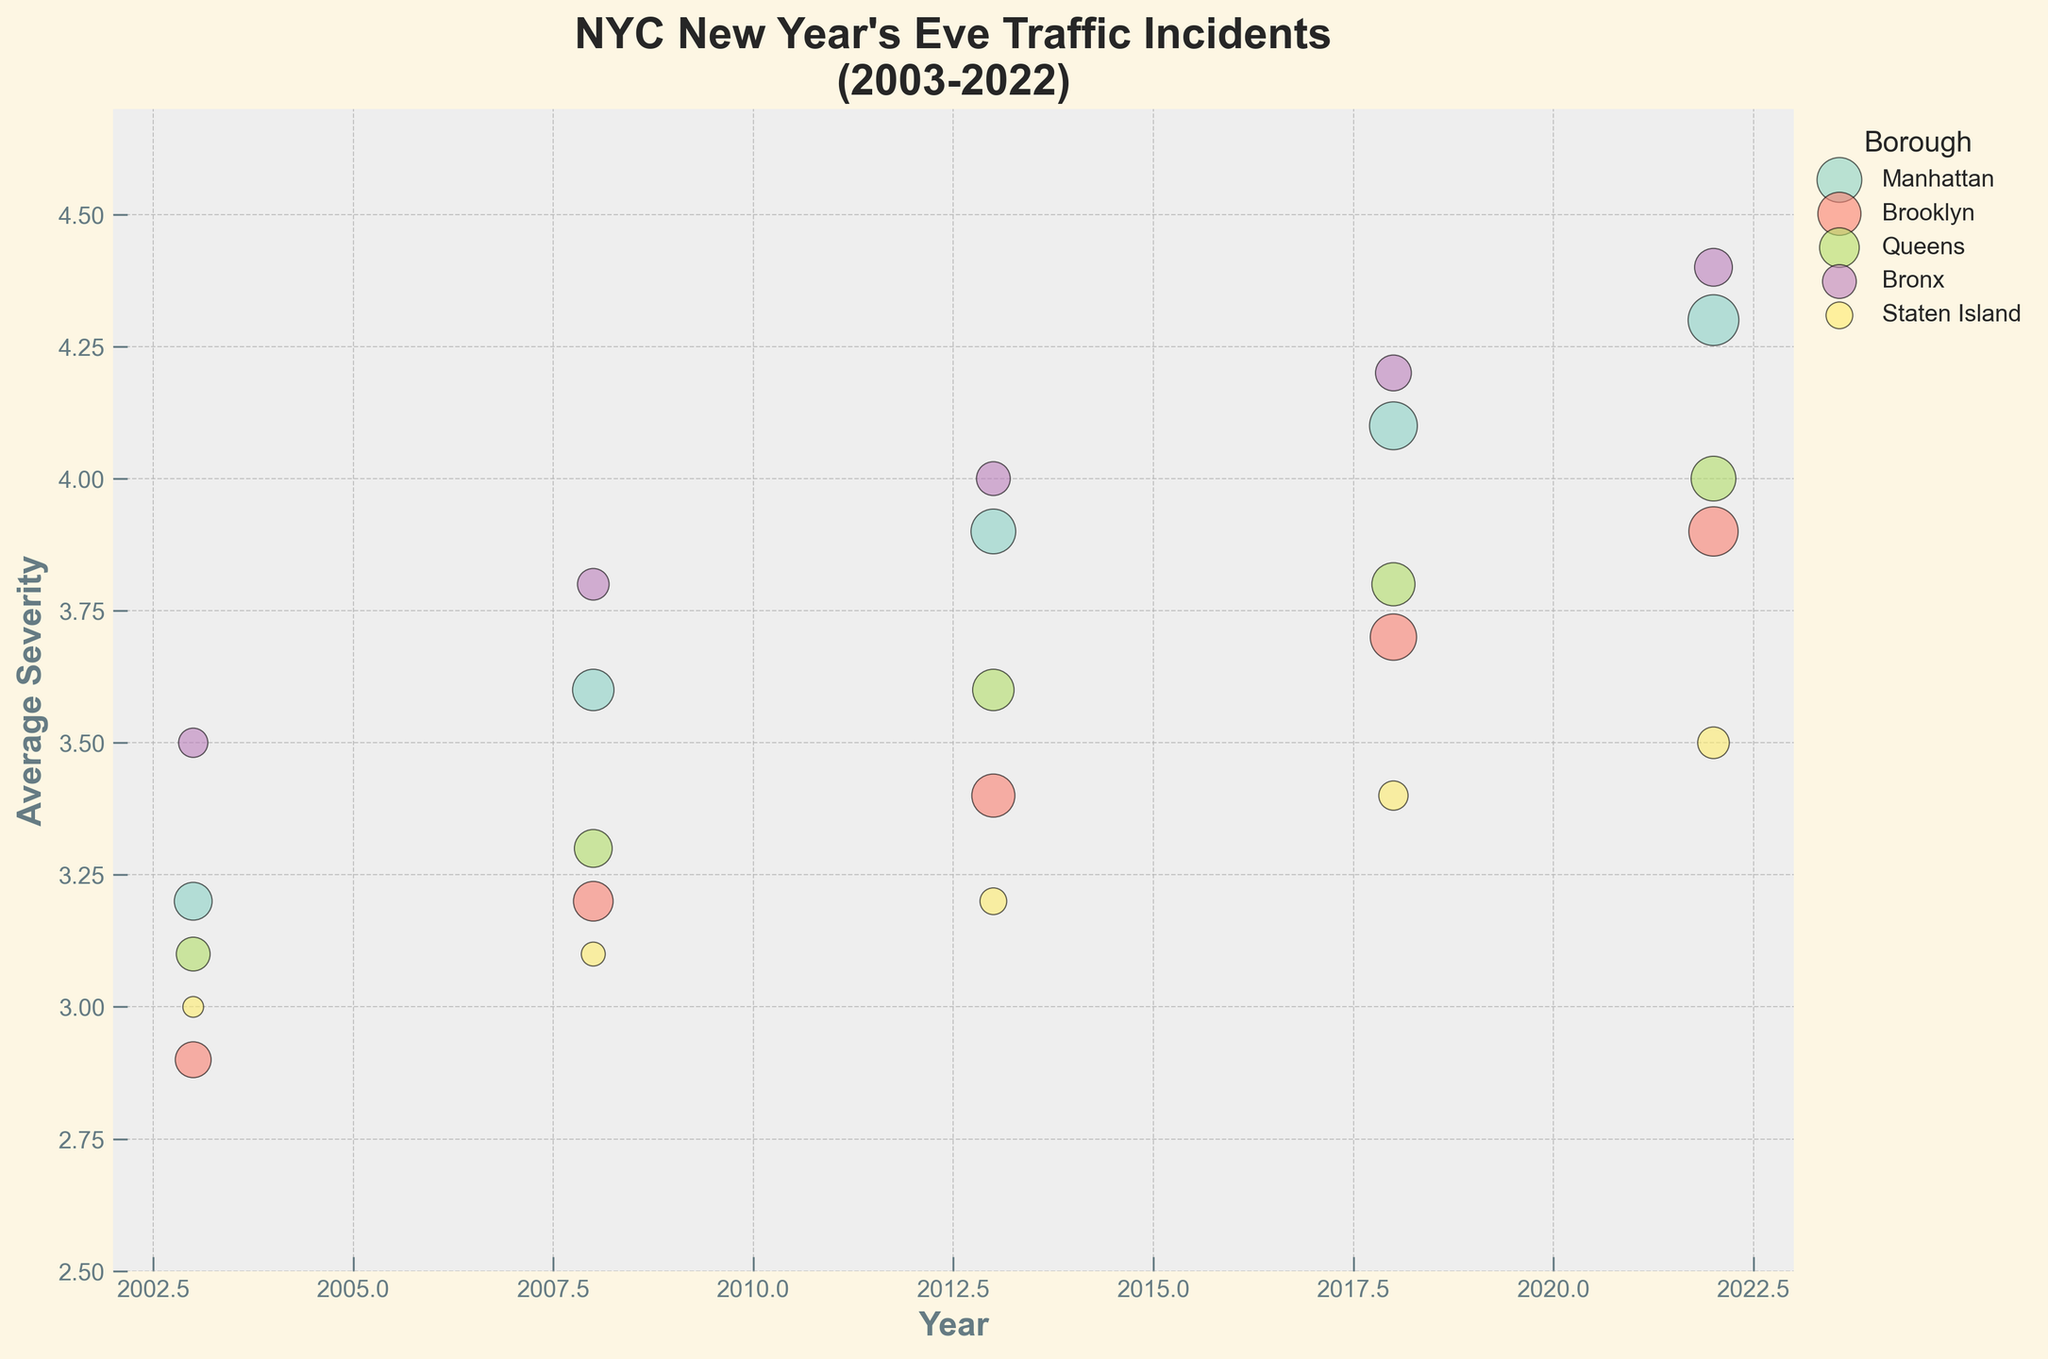What is the title of the figure? The title of the figure is shown at the top and is often the first thing to identify. It provides context about the visualization.
Answer: NYC New Year's Eve Traffic Incidents (2003-2022) Which borough had the highest average severity in 2022? To answer this, look at the average severity (y-axis values) for the year 2022 and identify which borough's data point is the highest.
Answer: Bronx How many traffic incidents were there in Brooklyn in 2018? Find the data point for Brooklyn in the year 2018 and look at the size of the bubble. The code mentions that the bubble size is proportional to the number of incidents.
Answer: 75 Which borough shows a consistent increase in incidents from 2003 to 2022? By comparing the bubble sizes across the years for each borough, identify the one which shows a clear upward trend in size.
Answer: Manhattan What is the average severity across all boroughs in 2013? To find this, look at the average severity value (y-axis) for each borough in 2013, add them up and then divide by the number of boroughs: (3.9 + 3.4 + 3.6 + 4.0 + 3.2) / 5 = 18.1 / 5
Answer: 3.62 Which borough had the lowest average severity in 2008? Check the average severity (y-axis values) for the year 2008 and find the lowest among those values for each borough's data points.
Answer: Staten Island What is the total number of incidents in Queens over the presented years? Sum the number of incidents in Queens for each available year: 40 (2003) + 50 (2008) + 60 (2013) + 65 (2018) + 70 (2022) = 285
Answer: 285 Comparing 2003 and 2022, which borough had the greatest increase in severity? Calculate the difference in severity for each borough between 2003 and 2022, then find the borough with the largest increase: Manhattan (4.3 - 3.2 = 1.1), Brooklyn (3.9 - 2.9 = 1.0), Queens (4.0 - 3.1 = 0.9), Bronx (4.4 - 3.5 = 0.9), Staten Island (3.5 - 3.0 = 0.5), greatest increase is Manhattan
Answer: Manhattan Is there any borough where the severity decreased from 2003 to 2022? Compare the average severity values for each borough between 2003 and 2022 to see if there is a decrease: Manhattan (+1.1), Brooklyn (+1.0), Queens (+0.9), Bronx (+0.9), Staten Island (+0.5), None of them show a decrease
Answer: No How does the bubble size for Manhattan in 2003 compare to Brooklyn in 2013? Look at the bubble sizes for Manhattan in 2003 and Brooklyn in 2013 and compare directly. Manhattan in 2003 has 50 incidents and Brooklyn in 2013 has 65 incidents, thus Brooklyn's bubble in 2013 is larger.
Answer: Brooklyn's bubble in 2013 is larger 